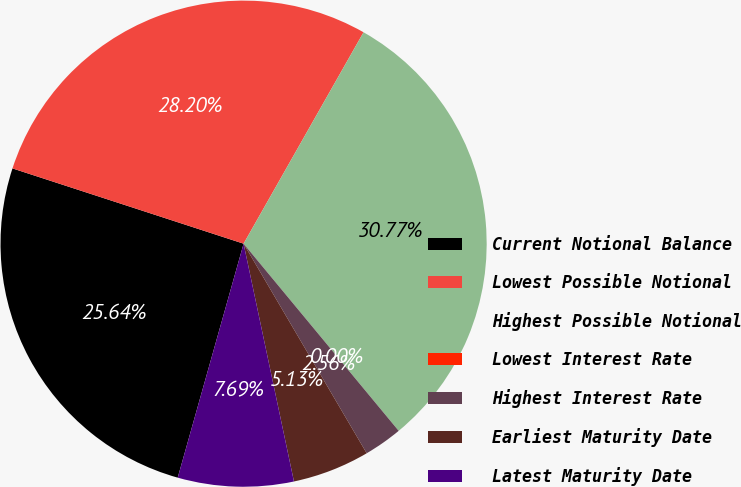Convert chart to OTSL. <chart><loc_0><loc_0><loc_500><loc_500><pie_chart><fcel>Current Notional Balance<fcel>Lowest Possible Notional<fcel>Highest Possible Notional<fcel>Lowest Interest Rate<fcel>Highest Interest Rate<fcel>Earliest Maturity Date<fcel>Latest Maturity Date<nl><fcel>25.64%<fcel>28.2%<fcel>30.77%<fcel>0.0%<fcel>2.56%<fcel>5.13%<fcel>7.69%<nl></chart> 